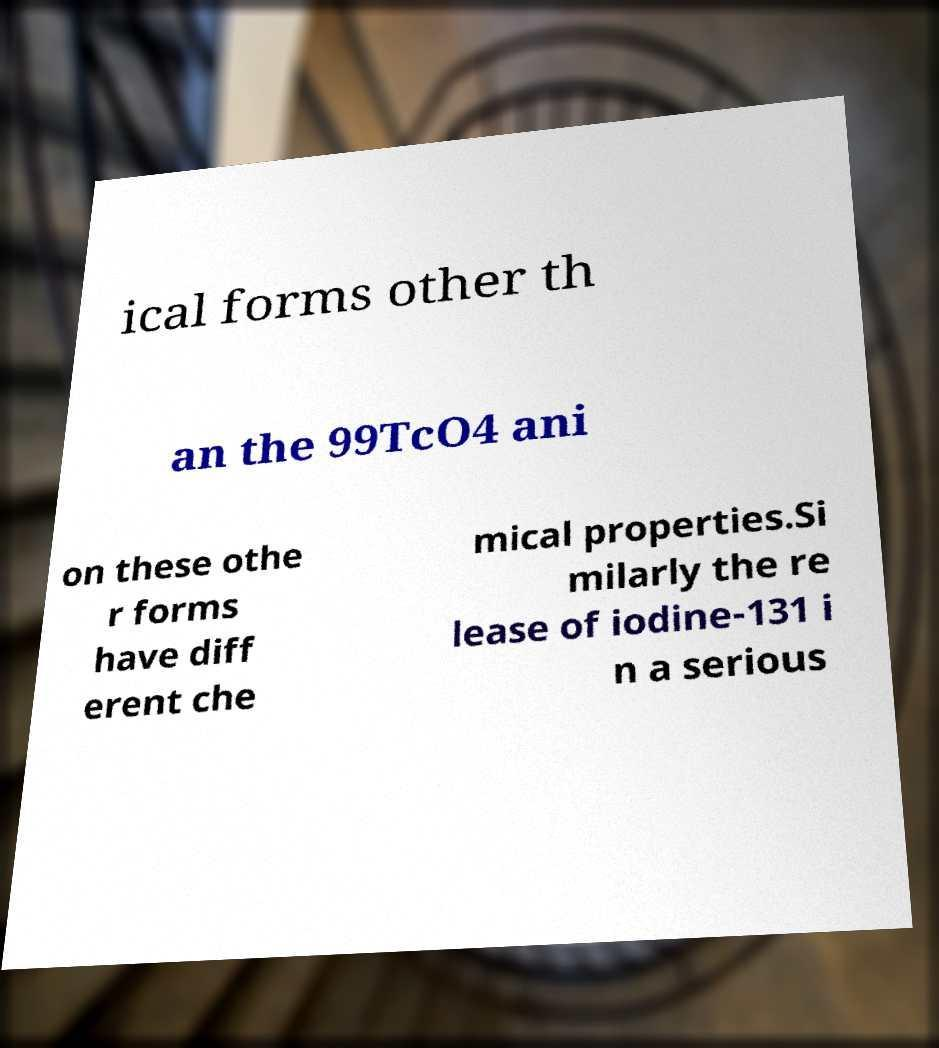Could you assist in decoding the text presented in this image and type it out clearly? ical forms other th an the 99TcO4 ani on these othe r forms have diff erent che mical properties.Si milarly the re lease of iodine-131 i n a serious 